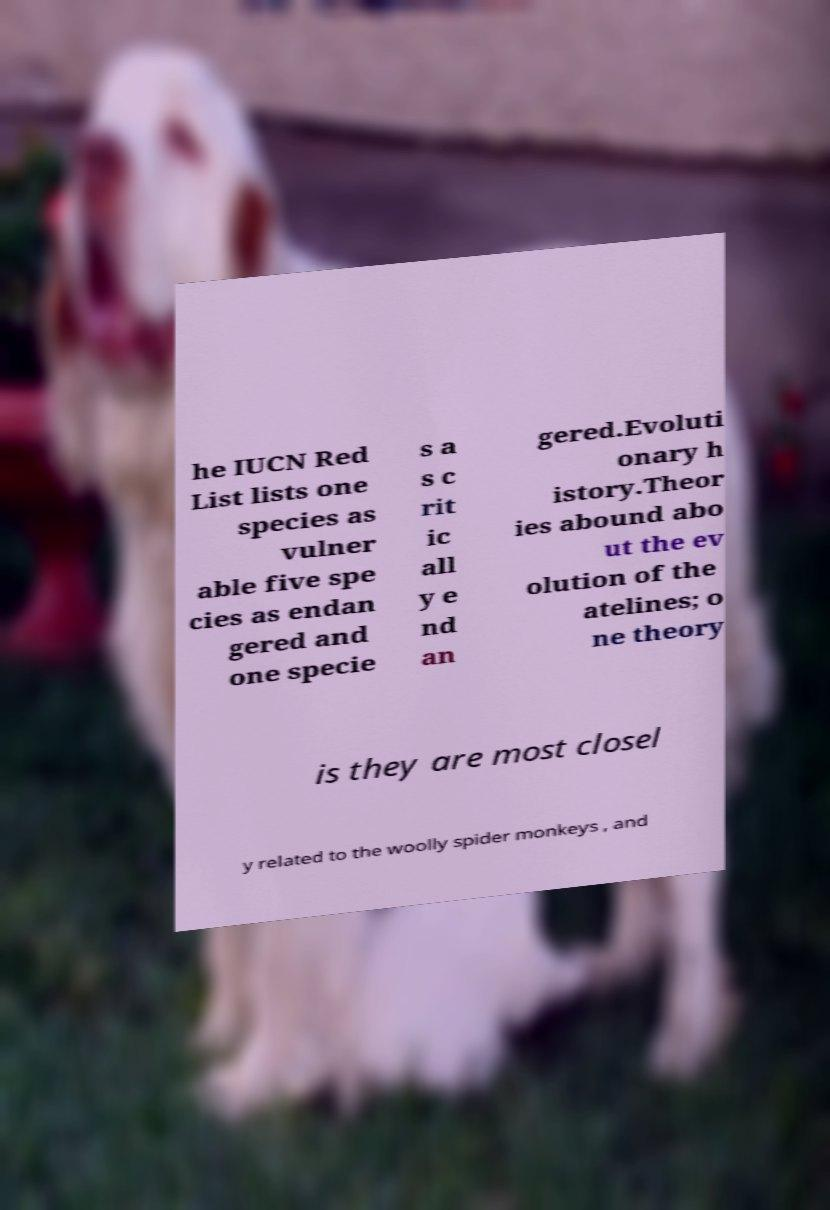For documentation purposes, I need the text within this image transcribed. Could you provide that? he IUCN Red List lists one species as vulner able five spe cies as endan gered and one specie s a s c rit ic all y e nd an gered.Evoluti onary h istory.Theor ies abound abo ut the ev olution of the atelines; o ne theory is they are most closel y related to the woolly spider monkeys , and 